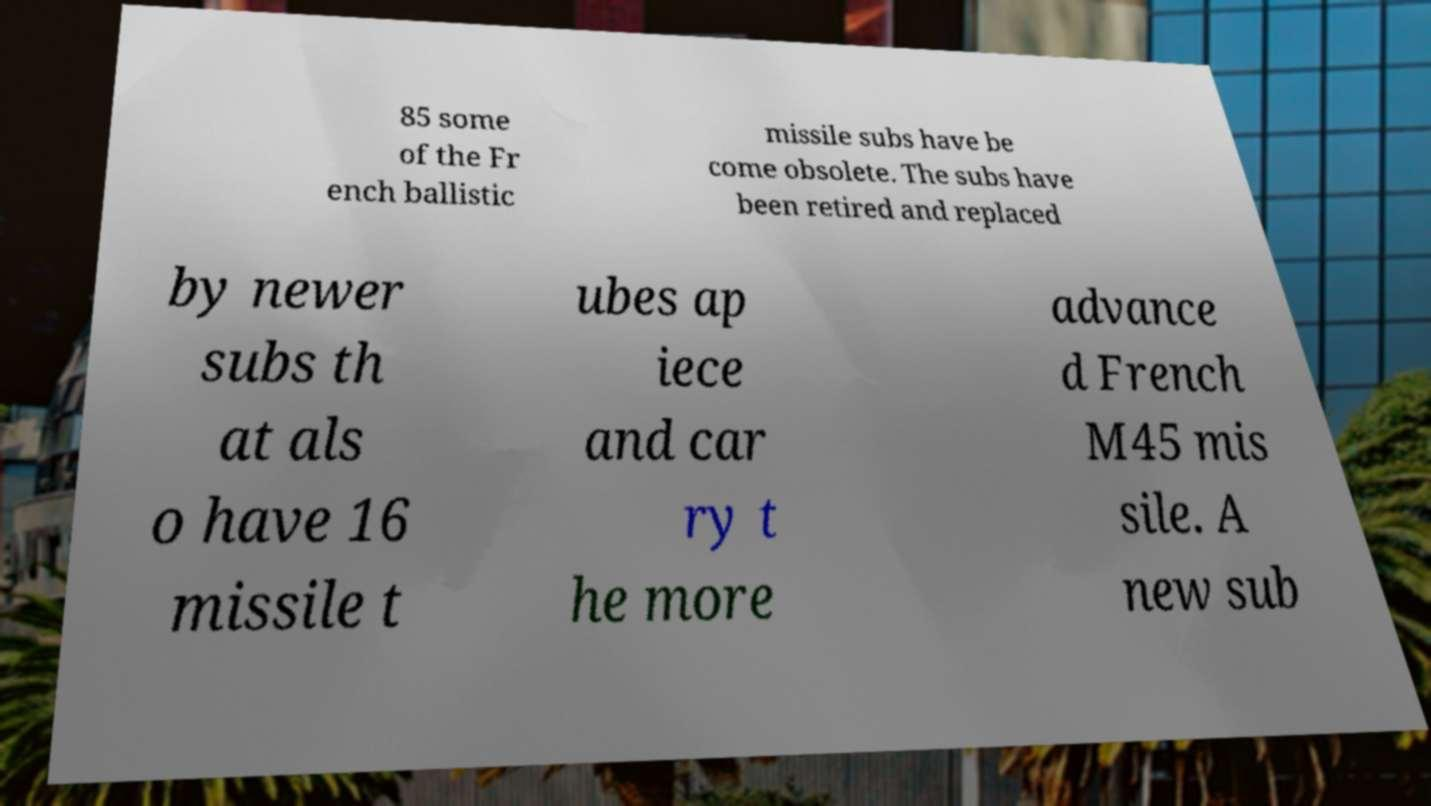Please read and relay the text visible in this image. What does it say? 85 some of the Fr ench ballistic missile subs have be come obsolete. The subs have been retired and replaced by newer subs th at als o have 16 missile t ubes ap iece and car ry t he more advance d French M45 mis sile. A new sub 